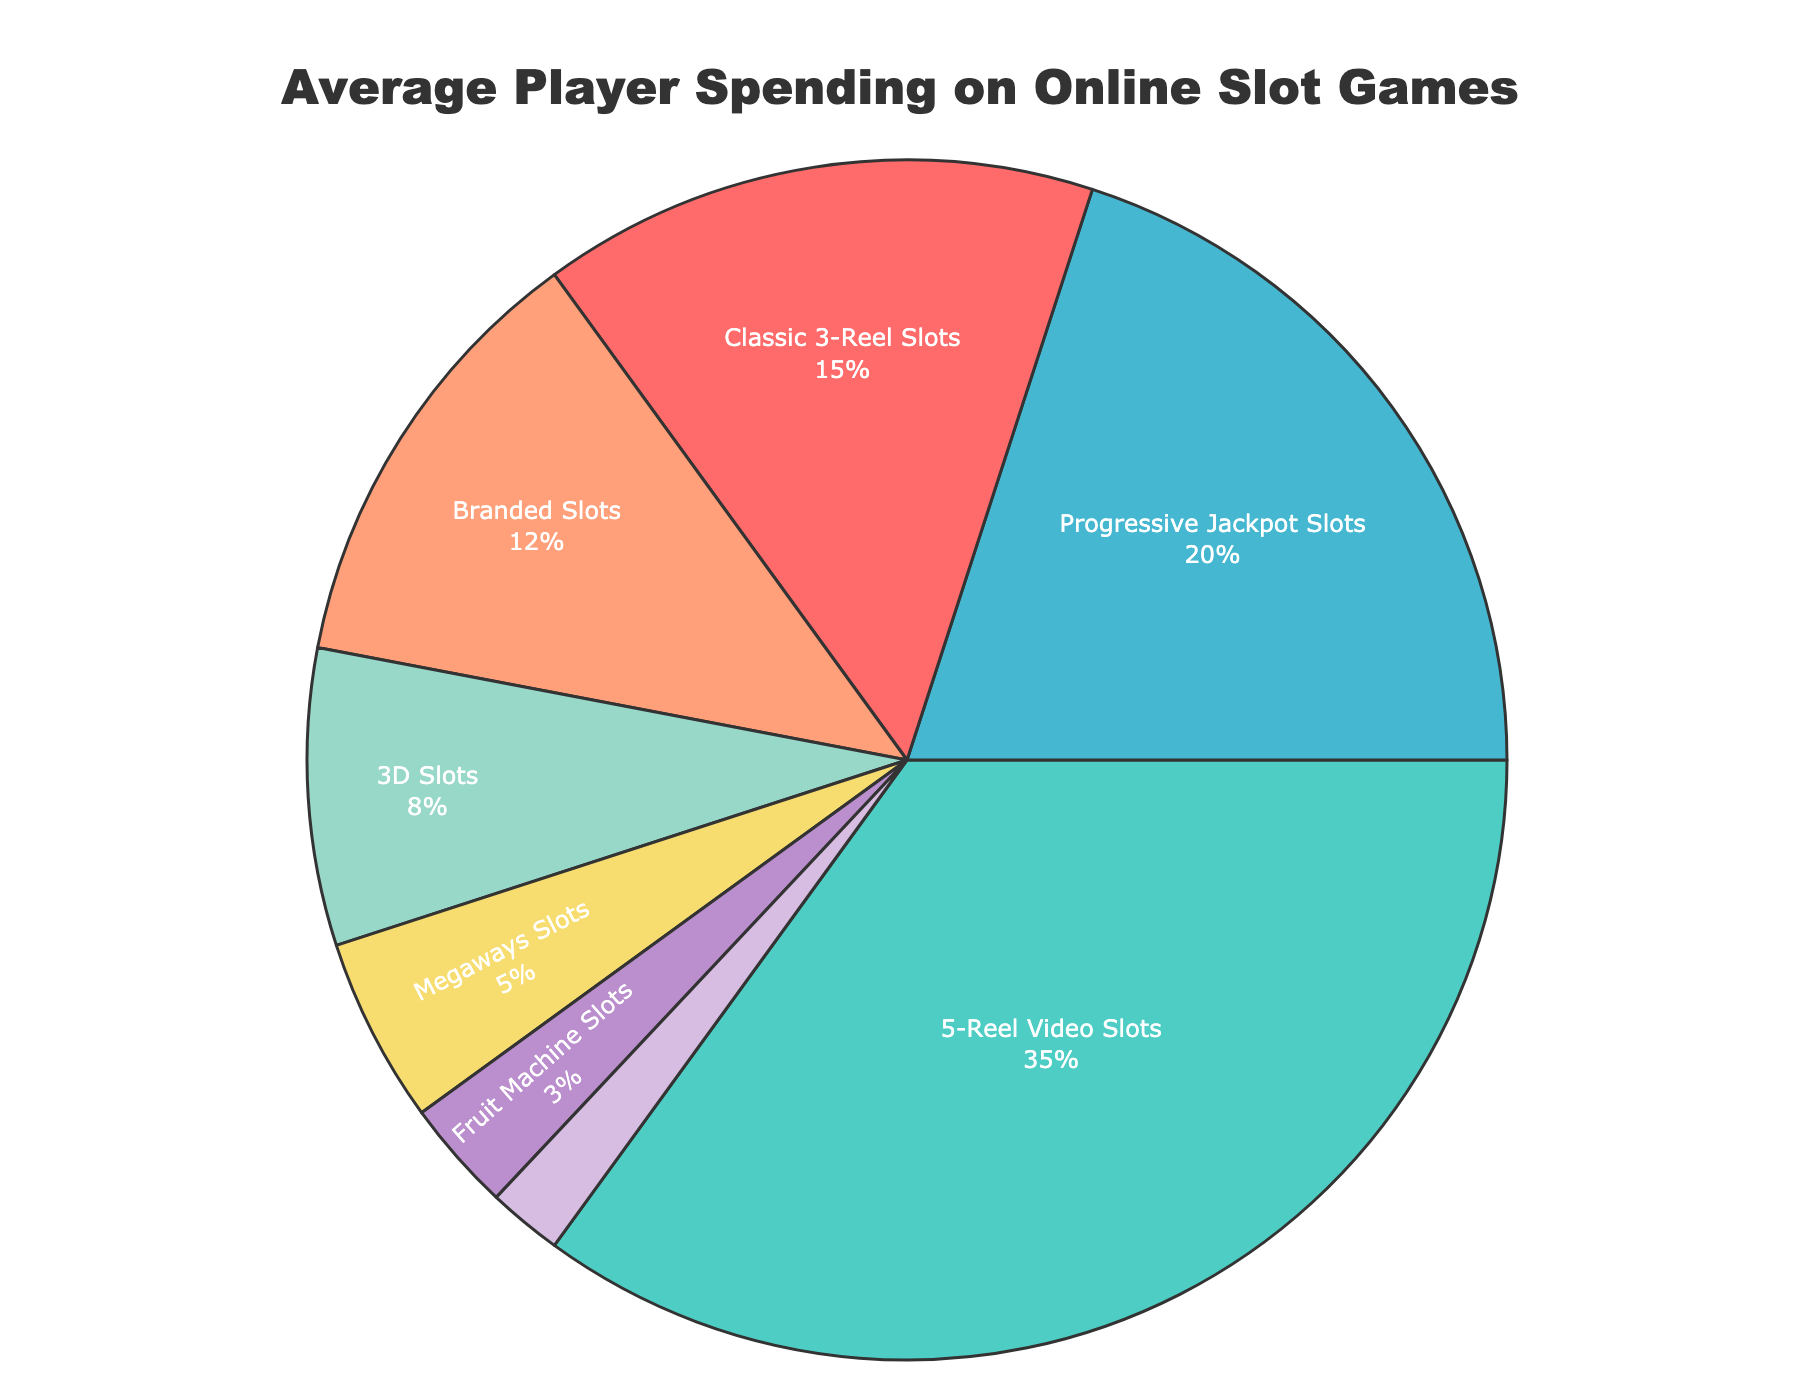What percentage of spending is on 5-Reel Video Slots? Locate the segment labeled "5-Reel Video Slots" on the pie chart and note the percentage value.
Answer: 35% Which game type has the smallest percentage of average spending? Identify the segment with the smallest size and reference its label "Cluster Pays Slots".
Answer: Cluster Pays Slots How much greater is the spending on Progressive Jackpot Slots compared to 3D Slots? Locate the values for Progressive Jackpot Slots (20%) and 3D Slots (8%). Calculate the difference: 20% - 8%.
Answer: 12% What is the combined percentage of spending on Classic 3-Reel Slots and Branded Slots? Locate the values for Classic 3-Reel Slots (15%) and Branded Slots (12%). Sum the values: 15% + 12%.
Answer: 27% Which type of slot game has the third highest average spending? Based on the segment sizes and labels, identify the segment with the third highest value, which is Progressive Jackpot Slots at 20%.
Answer: Progressive Jackpot Slots Is the spending on Fruit Machine Slots less than or equal to 4%? Locate the value for Fruit Machine Slots (3%) and check if it is ≤ 4%.
Answer: Yes What is the total percentage of spending on the three least popular slot games? Identify the three smallest segments: Cluster Pays Slots (2%), Fruit Machine Slots (3%), and Megaways Slots (5%). Sum the values: 2% + 3% + 5%.
Answer: 10% What color represents Branded Slots in the chart? Find the segment labeled "Branded Slots" and note its color. In this case, it is a purple shade.
Answer: Purple 